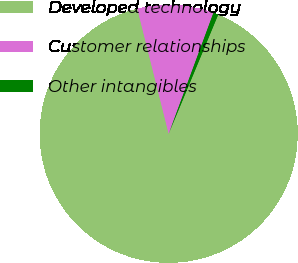<chart> <loc_0><loc_0><loc_500><loc_500><pie_chart><fcel>Developed technology<fcel>Customer relationships<fcel>Other intangibles<nl><fcel>89.82%<fcel>9.55%<fcel>0.63%<nl></chart> 